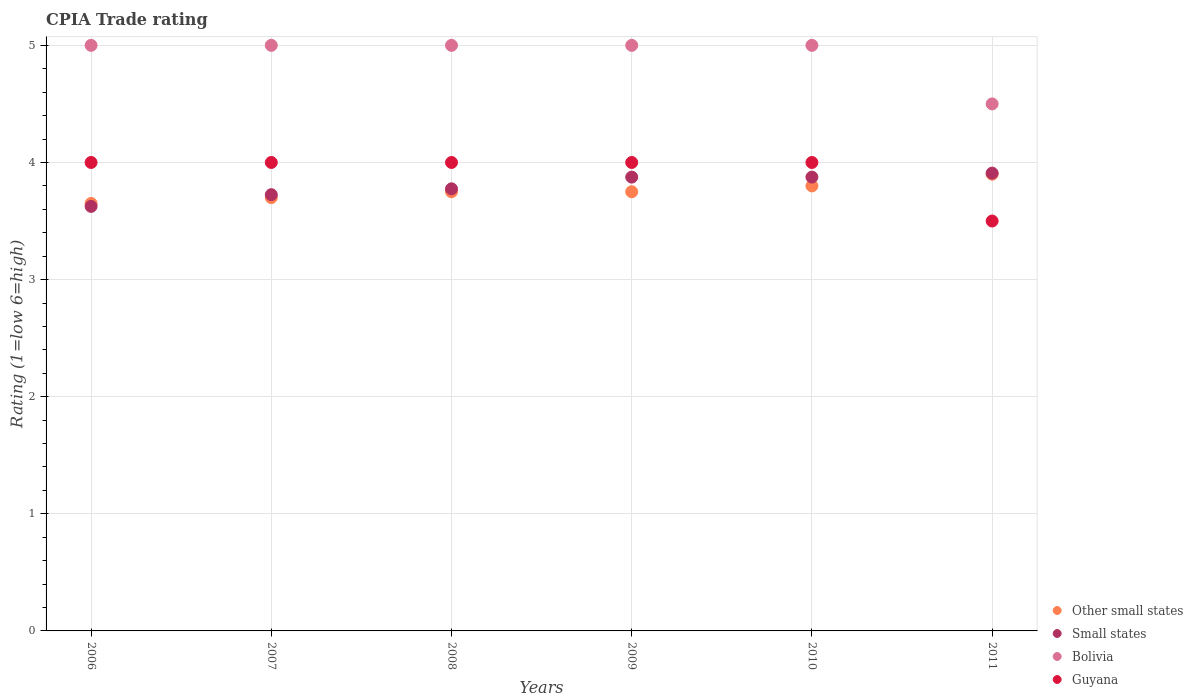Is the number of dotlines equal to the number of legend labels?
Give a very brief answer. Yes. What is the CPIA rating in Guyana in 2010?
Your response must be concise. 4. Across all years, what is the minimum CPIA rating in Small states?
Ensure brevity in your answer.  3.62. In which year was the CPIA rating in Other small states minimum?
Offer a very short reply. 2006. What is the average CPIA rating in Other small states per year?
Your answer should be compact. 3.76. In the year 2007, what is the difference between the CPIA rating in Bolivia and CPIA rating in Guyana?
Make the answer very short. 1. In how many years, is the CPIA rating in Bolivia greater than 4.6?
Your answer should be compact. 5. What is the ratio of the CPIA rating in Small states in 2009 to that in 2011?
Provide a short and direct response. 0.99. Is the CPIA rating in Other small states in 2008 less than that in 2009?
Offer a terse response. No. What is the difference between the highest and the second highest CPIA rating in Small states?
Your answer should be compact. 0.03. What is the difference between the highest and the lowest CPIA rating in Other small states?
Make the answer very short. 0.25. In how many years, is the CPIA rating in Bolivia greater than the average CPIA rating in Bolivia taken over all years?
Provide a succinct answer. 5. Is the sum of the CPIA rating in Small states in 2006 and 2011 greater than the maximum CPIA rating in Guyana across all years?
Your response must be concise. Yes. Does the CPIA rating in Bolivia monotonically increase over the years?
Make the answer very short. No. Is the CPIA rating in Small states strictly greater than the CPIA rating in Other small states over the years?
Your answer should be very brief. No. Is the CPIA rating in Bolivia strictly less than the CPIA rating in Small states over the years?
Make the answer very short. No. How many years are there in the graph?
Your response must be concise. 6. What is the difference between two consecutive major ticks on the Y-axis?
Make the answer very short. 1. Are the values on the major ticks of Y-axis written in scientific E-notation?
Offer a terse response. No. Does the graph contain grids?
Offer a terse response. Yes. Where does the legend appear in the graph?
Give a very brief answer. Bottom right. How many legend labels are there?
Ensure brevity in your answer.  4. How are the legend labels stacked?
Your answer should be compact. Vertical. What is the title of the graph?
Make the answer very short. CPIA Trade rating. What is the Rating (1=low 6=high) in Other small states in 2006?
Give a very brief answer. 3.65. What is the Rating (1=low 6=high) in Small states in 2006?
Provide a short and direct response. 3.62. What is the Rating (1=low 6=high) in Guyana in 2006?
Give a very brief answer. 4. What is the Rating (1=low 6=high) of Other small states in 2007?
Ensure brevity in your answer.  3.7. What is the Rating (1=low 6=high) in Small states in 2007?
Make the answer very short. 3.73. What is the Rating (1=low 6=high) in Guyana in 2007?
Ensure brevity in your answer.  4. What is the Rating (1=low 6=high) of Other small states in 2008?
Offer a very short reply. 3.75. What is the Rating (1=low 6=high) in Small states in 2008?
Ensure brevity in your answer.  3.77. What is the Rating (1=low 6=high) of Bolivia in 2008?
Your response must be concise. 5. What is the Rating (1=low 6=high) of Guyana in 2008?
Your answer should be compact. 4. What is the Rating (1=low 6=high) of Other small states in 2009?
Give a very brief answer. 3.75. What is the Rating (1=low 6=high) in Small states in 2009?
Give a very brief answer. 3.88. What is the Rating (1=low 6=high) of Small states in 2010?
Offer a very short reply. 3.88. What is the Rating (1=low 6=high) of Bolivia in 2010?
Offer a very short reply. 5. What is the Rating (1=low 6=high) in Guyana in 2010?
Give a very brief answer. 4. What is the Rating (1=low 6=high) in Other small states in 2011?
Make the answer very short. 3.9. What is the Rating (1=low 6=high) in Small states in 2011?
Ensure brevity in your answer.  3.91. What is the Rating (1=low 6=high) in Bolivia in 2011?
Ensure brevity in your answer.  4.5. What is the Rating (1=low 6=high) in Guyana in 2011?
Provide a succinct answer. 3.5. Across all years, what is the maximum Rating (1=low 6=high) of Small states?
Make the answer very short. 3.91. Across all years, what is the minimum Rating (1=low 6=high) in Other small states?
Your answer should be very brief. 3.65. Across all years, what is the minimum Rating (1=low 6=high) in Small states?
Your answer should be very brief. 3.62. Across all years, what is the minimum Rating (1=low 6=high) of Guyana?
Give a very brief answer. 3.5. What is the total Rating (1=low 6=high) in Other small states in the graph?
Your response must be concise. 22.55. What is the total Rating (1=low 6=high) in Small states in the graph?
Your response must be concise. 22.78. What is the total Rating (1=low 6=high) in Bolivia in the graph?
Your answer should be compact. 29.5. What is the total Rating (1=low 6=high) of Guyana in the graph?
Your answer should be very brief. 23.5. What is the difference between the Rating (1=low 6=high) of Other small states in 2006 and that in 2007?
Keep it short and to the point. -0.05. What is the difference between the Rating (1=low 6=high) in Small states in 2006 and that in 2007?
Provide a succinct answer. -0.1. What is the difference between the Rating (1=low 6=high) of Guyana in 2006 and that in 2007?
Make the answer very short. 0. What is the difference between the Rating (1=low 6=high) of Small states in 2006 and that in 2008?
Give a very brief answer. -0.15. What is the difference between the Rating (1=low 6=high) of Bolivia in 2006 and that in 2008?
Provide a succinct answer. 0. What is the difference between the Rating (1=low 6=high) of Guyana in 2006 and that in 2008?
Your answer should be very brief. 0. What is the difference between the Rating (1=low 6=high) of Small states in 2006 and that in 2009?
Provide a short and direct response. -0.25. What is the difference between the Rating (1=low 6=high) in Small states in 2006 and that in 2010?
Your response must be concise. -0.25. What is the difference between the Rating (1=low 6=high) in Other small states in 2006 and that in 2011?
Your response must be concise. -0.25. What is the difference between the Rating (1=low 6=high) in Small states in 2006 and that in 2011?
Make the answer very short. -0.28. What is the difference between the Rating (1=low 6=high) in Bolivia in 2006 and that in 2011?
Your answer should be very brief. 0.5. What is the difference between the Rating (1=low 6=high) of Guyana in 2006 and that in 2011?
Your answer should be very brief. 0.5. What is the difference between the Rating (1=low 6=high) of Small states in 2007 and that in 2008?
Your response must be concise. -0.05. What is the difference between the Rating (1=low 6=high) of Bolivia in 2007 and that in 2009?
Your answer should be compact. 0. What is the difference between the Rating (1=low 6=high) of Guyana in 2007 and that in 2009?
Ensure brevity in your answer.  0. What is the difference between the Rating (1=low 6=high) of Other small states in 2007 and that in 2010?
Provide a succinct answer. -0.1. What is the difference between the Rating (1=low 6=high) in Bolivia in 2007 and that in 2010?
Offer a terse response. 0. What is the difference between the Rating (1=low 6=high) of Guyana in 2007 and that in 2010?
Give a very brief answer. 0. What is the difference between the Rating (1=low 6=high) of Small states in 2007 and that in 2011?
Give a very brief answer. -0.18. What is the difference between the Rating (1=low 6=high) in Bolivia in 2007 and that in 2011?
Provide a succinct answer. 0.5. What is the difference between the Rating (1=low 6=high) of Guyana in 2007 and that in 2011?
Offer a terse response. 0.5. What is the difference between the Rating (1=low 6=high) of Small states in 2008 and that in 2009?
Your answer should be compact. -0.1. What is the difference between the Rating (1=low 6=high) in Bolivia in 2008 and that in 2009?
Offer a very short reply. 0. What is the difference between the Rating (1=low 6=high) of Guyana in 2008 and that in 2009?
Ensure brevity in your answer.  0. What is the difference between the Rating (1=low 6=high) of Other small states in 2008 and that in 2010?
Provide a short and direct response. -0.05. What is the difference between the Rating (1=low 6=high) in Small states in 2008 and that in 2010?
Make the answer very short. -0.1. What is the difference between the Rating (1=low 6=high) in Bolivia in 2008 and that in 2010?
Your answer should be very brief. 0. What is the difference between the Rating (1=low 6=high) of Guyana in 2008 and that in 2010?
Provide a succinct answer. 0. What is the difference between the Rating (1=low 6=high) of Other small states in 2008 and that in 2011?
Your answer should be very brief. -0.15. What is the difference between the Rating (1=low 6=high) in Small states in 2008 and that in 2011?
Make the answer very short. -0.13. What is the difference between the Rating (1=low 6=high) of Bolivia in 2008 and that in 2011?
Give a very brief answer. 0.5. What is the difference between the Rating (1=low 6=high) of Guyana in 2008 and that in 2011?
Offer a terse response. 0.5. What is the difference between the Rating (1=low 6=high) in Small states in 2009 and that in 2010?
Your response must be concise. 0. What is the difference between the Rating (1=low 6=high) of Bolivia in 2009 and that in 2010?
Offer a very short reply. 0. What is the difference between the Rating (1=low 6=high) in Guyana in 2009 and that in 2010?
Your answer should be very brief. 0. What is the difference between the Rating (1=low 6=high) in Other small states in 2009 and that in 2011?
Your answer should be very brief. -0.15. What is the difference between the Rating (1=low 6=high) of Small states in 2009 and that in 2011?
Offer a very short reply. -0.03. What is the difference between the Rating (1=low 6=high) in Bolivia in 2009 and that in 2011?
Offer a terse response. 0.5. What is the difference between the Rating (1=low 6=high) of Small states in 2010 and that in 2011?
Ensure brevity in your answer.  -0.03. What is the difference between the Rating (1=low 6=high) in Bolivia in 2010 and that in 2011?
Make the answer very short. 0.5. What is the difference between the Rating (1=low 6=high) in Guyana in 2010 and that in 2011?
Offer a very short reply. 0.5. What is the difference between the Rating (1=low 6=high) in Other small states in 2006 and the Rating (1=low 6=high) in Small states in 2007?
Keep it short and to the point. -0.07. What is the difference between the Rating (1=low 6=high) of Other small states in 2006 and the Rating (1=low 6=high) of Bolivia in 2007?
Ensure brevity in your answer.  -1.35. What is the difference between the Rating (1=low 6=high) of Other small states in 2006 and the Rating (1=low 6=high) of Guyana in 2007?
Provide a succinct answer. -0.35. What is the difference between the Rating (1=low 6=high) in Small states in 2006 and the Rating (1=low 6=high) in Bolivia in 2007?
Offer a terse response. -1.38. What is the difference between the Rating (1=low 6=high) of Small states in 2006 and the Rating (1=low 6=high) of Guyana in 2007?
Give a very brief answer. -0.38. What is the difference between the Rating (1=low 6=high) in Other small states in 2006 and the Rating (1=low 6=high) in Small states in 2008?
Provide a succinct answer. -0.12. What is the difference between the Rating (1=low 6=high) of Other small states in 2006 and the Rating (1=low 6=high) of Bolivia in 2008?
Your answer should be very brief. -1.35. What is the difference between the Rating (1=low 6=high) in Other small states in 2006 and the Rating (1=low 6=high) in Guyana in 2008?
Provide a short and direct response. -0.35. What is the difference between the Rating (1=low 6=high) in Small states in 2006 and the Rating (1=low 6=high) in Bolivia in 2008?
Provide a succinct answer. -1.38. What is the difference between the Rating (1=low 6=high) in Small states in 2006 and the Rating (1=low 6=high) in Guyana in 2008?
Provide a succinct answer. -0.38. What is the difference between the Rating (1=low 6=high) of Bolivia in 2006 and the Rating (1=low 6=high) of Guyana in 2008?
Your response must be concise. 1. What is the difference between the Rating (1=low 6=high) in Other small states in 2006 and the Rating (1=low 6=high) in Small states in 2009?
Offer a very short reply. -0.23. What is the difference between the Rating (1=low 6=high) of Other small states in 2006 and the Rating (1=low 6=high) of Bolivia in 2009?
Keep it short and to the point. -1.35. What is the difference between the Rating (1=low 6=high) in Other small states in 2006 and the Rating (1=low 6=high) in Guyana in 2009?
Offer a terse response. -0.35. What is the difference between the Rating (1=low 6=high) in Small states in 2006 and the Rating (1=low 6=high) in Bolivia in 2009?
Provide a succinct answer. -1.38. What is the difference between the Rating (1=low 6=high) of Small states in 2006 and the Rating (1=low 6=high) of Guyana in 2009?
Ensure brevity in your answer.  -0.38. What is the difference between the Rating (1=low 6=high) in Other small states in 2006 and the Rating (1=low 6=high) in Small states in 2010?
Provide a short and direct response. -0.23. What is the difference between the Rating (1=low 6=high) of Other small states in 2006 and the Rating (1=low 6=high) of Bolivia in 2010?
Give a very brief answer. -1.35. What is the difference between the Rating (1=low 6=high) in Other small states in 2006 and the Rating (1=low 6=high) in Guyana in 2010?
Provide a succinct answer. -0.35. What is the difference between the Rating (1=low 6=high) of Small states in 2006 and the Rating (1=low 6=high) of Bolivia in 2010?
Your answer should be compact. -1.38. What is the difference between the Rating (1=low 6=high) in Small states in 2006 and the Rating (1=low 6=high) in Guyana in 2010?
Your answer should be very brief. -0.38. What is the difference between the Rating (1=low 6=high) in Other small states in 2006 and the Rating (1=low 6=high) in Small states in 2011?
Your response must be concise. -0.26. What is the difference between the Rating (1=low 6=high) in Other small states in 2006 and the Rating (1=low 6=high) in Bolivia in 2011?
Your response must be concise. -0.85. What is the difference between the Rating (1=low 6=high) in Small states in 2006 and the Rating (1=low 6=high) in Bolivia in 2011?
Provide a short and direct response. -0.88. What is the difference between the Rating (1=low 6=high) in Small states in 2006 and the Rating (1=low 6=high) in Guyana in 2011?
Offer a terse response. 0.12. What is the difference between the Rating (1=low 6=high) in Bolivia in 2006 and the Rating (1=low 6=high) in Guyana in 2011?
Give a very brief answer. 1.5. What is the difference between the Rating (1=low 6=high) of Other small states in 2007 and the Rating (1=low 6=high) of Small states in 2008?
Your answer should be very brief. -0.07. What is the difference between the Rating (1=low 6=high) of Small states in 2007 and the Rating (1=low 6=high) of Bolivia in 2008?
Your answer should be very brief. -1.27. What is the difference between the Rating (1=low 6=high) in Small states in 2007 and the Rating (1=low 6=high) in Guyana in 2008?
Provide a short and direct response. -0.28. What is the difference between the Rating (1=low 6=high) in Bolivia in 2007 and the Rating (1=low 6=high) in Guyana in 2008?
Provide a succinct answer. 1. What is the difference between the Rating (1=low 6=high) of Other small states in 2007 and the Rating (1=low 6=high) of Small states in 2009?
Provide a short and direct response. -0.17. What is the difference between the Rating (1=low 6=high) of Other small states in 2007 and the Rating (1=low 6=high) of Bolivia in 2009?
Your response must be concise. -1.3. What is the difference between the Rating (1=low 6=high) of Small states in 2007 and the Rating (1=low 6=high) of Bolivia in 2009?
Make the answer very short. -1.27. What is the difference between the Rating (1=low 6=high) in Small states in 2007 and the Rating (1=low 6=high) in Guyana in 2009?
Ensure brevity in your answer.  -0.28. What is the difference between the Rating (1=low 6=high) of Bolivia in 2007 and the Rating (1=low 6=high) of Guyana in 2009?
Provide a succinct answer. 1. What is the difference between the Rating (1=low 6=high) of Other small states in 2007 and the Rating (1=low 6=high) of Small states in 2010?
Offer a terse response. -0.17. What is the difference between the Rating (1=low 6=high) of Small states in 2007 and the Rating (1=low 6=high) of Bolivia in 2010?
Provide a short and direct response. -1.27. What is the difference between the Rating (1=low 6=high) of Small states in 2007 and the Rating (1=low 6=high) of Guyana in 2010?
Offer a very short reply. -0.28. What is the difference between the Rating (1=low 6=high) in Bolivia in 2007 and the Rating (1=low 6=high) in Guyana in 2010?
Your response must be concise. 1. What is the difference between the Rating (1=low 6=high) in Other small states in 2007 and the Rating (1=low 6=high) in Small states in 2011?
Give a very brief answer. -0.21. What is the difference between the Rating (1=low 6=high) of Other small states in 2007 and the Rating (1=low 6=high) of Guyana in 2011?
Provide a short and direct response. 0.2. What is the difference between the Rating (1=low 6=high) in Small states in 2007 and the Rating (1=low 6=high) in Bolivia in 2011?
Your answer should be compact. -0.78. What is the difference between the Rating (1=low 6=high) in Small states in 2007 and the Rating (1=low 6=high) in Guyana in 2011?
Provide a succinct answer. 0.23. What is the difference between the Rating (1=low 6=high) in Bolivia in 2007 and the Rating (1=low 6=high) in Guyana in 2011?
Make the answer very short. 1.5. What is the difference between the Rating (1=low 6=high) of Other small states in 2008 and the Rating (1=low 6=high) of Small states in 2009?
Ensure brevity in your answer.  -0.12. What is the difference between the Rating (1=low 6=high) in Other small states in 2008 and the Rating (1=low 6=high) in Bolivia in 2009?
Offer a terse response. -1.25. What is the difference between the Rating (1=low 6=high) in Other small states in 2008 and the Rating (1=low 6=high) in Guyana in 2009?
Make the answer very short. -0.25. What is the difference between the Rating (1=low 6=high) of Small states in 2008 and the Rating (1=low 6=high) of Bolivia in 2009?
Keep it short and to the point. -1.23. What is the difference between the Rating (1=low 6=high) of Small states in 2008 and the Rating (1=low 6=high) of Guyana in 2009?
Make the answer very short. -0.23. What is the difference between the Rating (1=low 6=high) in Bolivia in 2008 and the Rating (1=low 6=high) in Guyana in 2009?
Provide a short and direct response. 1. What is the difference between the Rating (1=low 6=high) of Other small states in 2008 and the Rating (1=low 6=high) of Small states in 2010?
Offer a terse response. -0.12. What is the difference between the Rating (1=low 6=high) of Other small states in 2008 and the Rating (1=low 6=high) of Bolivia in 2010?
Your answer should be compact. -1.25. What is the difference between the Rating (1=low 6=high) of Other small states in 2008 and the Rating (1=low 6=high) of Guyana in 2010?
Give a very brief answer. -0.25. What is the difference between the Rating (1=low 6=high) of Small states in 2008 and the Rating (1=low 6=high) of Bolivia in 2010?
Offer a very short reply. -1.23. What is the difference between the Rating (1=low 6=high) in Small states in 2008 and the Rating (1=low 6=high) in Guyana in 2010?
Keep it short and to the point. -0.23. What is the difference between the Rating (1=low 6=high) in Other small states in 2008 and the Rating (1=low 6=high) in Small states in 2011?
Your response must be concise. -0.16. What is the difference between the Rating (1=low 6=high) in Other small states in 2008 and the Rating (1=low 6=high) in Bolivia in 2011?
Provide a short and direct response. -0.75. What is the difference between the Rating (1=low 6=high) in Small states in 2008 and the Rating (1=low 6=high) in Bolivia in 2011?
Keep it short and to the point. -0.72. What is the difference between the Rating (1=low 6=high) in Small states in 2008 and the Rating (1=low 6=high) in Guyana in 2011?
Provide a succinct answer. 0.28. What is the difference between the Rating (1=low 6=high) of Bolivia in 2008 and the Rating (1=low 6=high) of Guyana in 2011?
Make the answer very short. 1.5. What is the difference between the Rating (1=low 6=high) in Other small states in 2009 and the Rating (1=low 6=high) in Small states in 2010?
Ensure brevity in your answer.  -0.12. What is the difference between the Rating (1=low 6=high) in Other small states in 2009 and the Rating (1=low 6=high) in Bolivia in 2010?
Your response must be concise. -1.25. What is the difference between the Rating (1=low 6=high) of Small states in 2009 and the Rating (1=low 6=high) of Bolivia in 2010?
Your answer should be compact. -1.12. What is the difference between the Rating (1=low 6=high) in Small states in 2009 and the Rating (1=low 6=high) in Guyana in 2010?
Offer a very short reply. -0.12. What is the difference between the Rating (1=low 6=high) in Bolivia in 2009 and the Rating (1=low 6=high) in Guyana in 2010?
Give a very brief answer. 1. What is the difference between the Rating (1=low 6=high) of Other small states in 2009 and the Rating (1=low 6=high) of Small states in 2011?
Make the answer very short. -0.16. What is the difference between the Rating (1=low 6=high) in Other small states in 2009 and the Rating (1=low 6=high) in Bolivia in 2011?
Offer a terse response. -0.75. What is the difference between the Rating (1=low 6=high) of Small states in 2009 and the Rating (1=low 6=high) of Bolivia in 2011?
Keep it short and to the point. -0.62. What is the difference between the Rating (1=low 6=high) of Small states in 2009 and the Rating (1=low 6=high) of Guyana in 2011?
Offer a very short reply. 0.38. What is the difference between the Rating (1=low 6=high) in Bolivia in 2009 and the Rating (1=low 6=high) in Guyana in 2011?
Keep it short and to the point. 1.5. What is the difference between the Rating (1=low 6=high) in Other small states in 2010 and the Rating (1=low 6=high) in Small states in 2011?
Your answer should be very brief. -0.11. What is the difference between the Rating (1=low 6=high) of Small states in 2010 and the Rating (1=low 6=high) of Bolivia in 2011?
Provide a succinct answer. -0.62. What is the difference between the Rating (1=low 6=high) in Small states in 2010 and the Rating (1=low 6=high) in Guyana in 2011?
Give a very brief answer. 0.38. What is the difference between the Rating (1=low 6=high) of Bolivia in 2010 and the Rating (1=low 6=high) of Guyana in 2011?
Keep it short and to the point. 1.5. What is the average Rating (1=low 6=high) of Other small states per year?
Ensure brevity in your answer.  3.76. What is the average Rating (1=low 6=high) in Small states per year?
Your answer should be very brief. 3.8. What is the average Rating (1=low 6=high) in Bolivia per year?
Offer a very short reply. 4.92. What is the average Rating (1=low 6=high) in Guyana per year?
Give a very brief answer. 3.92. In the year 2006, what is the difference between the Rating (1=low 6=high) in Other small states and Rating (1=low 6=high) in Small states?
Ensure brevity in your answer.  0.03. In the year 2006, what is the difference between the Rating (1=low 6=high) in Other small states and Rating (1=low 6=high) in Bolivia?
Keep it short and to the point. -1.35. In the year 2006, what is the difference between the Rating (1=low 6=high) in Other small states and Rating (1=low 6=high) in Guyana?
Provide a succinct answer. -0.35. In the year 2006, what is the difference between the Rating (1=low 6=high) in Small states and Rating (1=low 6=high) in Bolivia?
Give a very brief answer. -1.38. In the year 2006, what is the difference between the Rating (1=low 6=high) in Small states and Rating (1=low 6=high) in Guyana?
Keep it short and to the point. -0.38. In the year 2006, what is the difference between the Rating (1=low 6=high) in Bolivia and Rating (1=low 6=high) in Guyana?
Offer a very short reply. 1. In the year 2007, what is the difference between the Rating (1=low 6=high) of Other small states and Rating (1=low 6=high) of Small states?
Keep it short and to the point. -0.03. In the year 2007, what is the difference between the Rating (1=low 6=high) of Small states and Rating (1=low 6=high) of Bolivia?
Ensure brevity in your answer.  -1.27. In the year 2007, what is the difference between the Rating (1=low 6=high) in Small states and Rating (1=low 6=high) in Guyana?
Your response must be concise. -0.28. In the year 2008, what is the difference between the Rating (1=low 6=high) of Other small states and Rating (1=low 6=high) of Small states?
Offer a terse response. -0.03. In the year 2008, what is the difference between the Rating (1=low 6=high) of Other small states and Rating (1=low 6=high) of Bolivia?
Ensure brevity in your answer.  -1.25. In the year 2008, what is the difference between the Rating (1=low 6=high) in Small states and Rating (1=low 6=high) in Bolivia?
Keep it short and to the point. -1.23. In the year 2008, what is the difference between the Rating (1=low 6=high) in Small states and Rating (1=low 6=high) in Guyana?
Ensure brevity in your answer.  -0.23. In the year 2009, what is the difference between the Rating (1=low 6=high) in Other small states and Rating (1=low 6=high) in Small states?
Your answer should be very brief. -0.12. In the year 2009, what is the difference between the Rating (1=low 6=high) of Other small states and Rating (1=low 6=high) of Bolivia?
Keep it short and to the point. -1.25. In the year 2009, what is the difference between the Rating (1=low 6=high) in Small states and Rating (1=low 6=high) in Bolivia?
Provide a short and direct response. -1.12. In the year 2009, what is the difference between the Rating (1=low 6=high) of Small states and Rating (1=low 6=high) of Guyana?
Your answer should be compact. -0.12. In the year 2009, what is the difference between the Rating (1=low 6=high) in Bolivia and Rating (1=low 6=high) in Guyana?
Provide a short and direct response. 1. In the year 2010, what is the difference between the Rating (1=low 6=high) in Other small states and Rating (1=low 6=high) in Small states?
Ensure brevity in your answer.  -0.07. In the year 2010, what is the difference between the Rating (1=low 6=high) of Other small states and Rating (1=low 6=high) of Bolivia?
Provide a succinct answer. -1.2. In the year 2010, what is the difference between the Rating (1=low 6=high) of Other small states and Rating (1=low 6=high) of Guyana?
Keep it short and to the point. -0.2. In the year 2010, what is the difference between the Rating (1=low 6=high) in Small states and Rating (1=low 6=high) in Bolivia?
Ensure brevity in your answer.  -1.12. In the year 2010, what is the difference between the Rating (1=low 6=high) in Small states and Rating (1=low 6=high) in Guyana?
Your answer should be very brief. -0.12. In the year 2010, what is the difference between the Rating (1=low 6=high) of Bolivia and Rating (1=low 6=high) of Guyana?
Provide a succinct answer. 1. In the year 2011, what is the difference between the Rating (1=low 6=high) of Other small states and Rating (1=low 6=high) of Small states?
Keep it short and to the point. -0.01. In the year 2011, what is the difference between the Rating (1=low 6=high) of Small states and Rating (1=low 6=high) of Bolivia?
Offer a very short reply. -0.59. In the year 2011, what is the difference between the Rating (1=low 6=high) in Small states and Rating (1=low 6=high) in Guyana?
Your answer should be compact. 0.41. In the year 2011, what is the difference between the Rating (1=low 6=high) in Bolivia and Rating (1=low 6=high) in Guyana?
Your answer should be compact. 1. What is the ratio of the Rating (1=low 6=high) in Other small states in 2006 to that in 2007?
Your answer should be compact. 0.99. What is the ratio of the Rating (1=low 6=high) in Small states in 2006 to that in 2007?
Offer a terse response. 0.97. What is the ratio of the Rating (1=low 6=high) in Bolivia in 2006 to that in 2007?
Provide a short and direct response. 1. What is the ratio of the Rating (1=low 6=high) of Other small states in 2006 to that in 2008?
Your answer should be very brief. 0.97. What is the ratio of the Rating (1=low 6=high) of Small states in 2006 to that in 2008?
Your answer should be very brief. 0.96. What is the ratio of the Rating (1=low 6=high) of Bolivia in 2006 to that in 2008?
Offer a very short reply. 1. What is the ratio of the Rating (1=low 6=high) in Guyana in 2006 to that in 2008?
Your answer should be compact. 1. What is the ratio of the Rating (1=low 6=high) in Other small states in 2006 to that in 2009?
Make the answer very short. 0.97. What is the ratio of the Rating (1=low 6=high) in Small states in 2006 to that in 2009?
Ensure brevity in your answer.  0.94. What is the ratio of the Rating (1=low 6=high) of Guyana in 2006 to that in 2009?
Offer a terse response. 1. What is the ratio of the Rating (1=low 6=high) of Other small states in 2006 to that in 2010?
Provide a succinct answer. 0.96. What is the ratio of the Rating (1=low 6=high) in Small states in 2006 to that in 2010?
Offer a very short reply. 0.94. What is the ratio of the Rating (1=low 6=high) in Other small states in 2006 to that in 2011?
Your answer should be compact. 0.94. What is the ratio of the Rating (1=low 6=high) of Small states in 2006 to that in 2011?
Make the answer very short. 0.93. What is the ratio of the Rating (1=low 6=high) of Guyana in 2006 to that in 2011?
Provide a succinct answer. 1.14. What is the ratio of the Rating (1=low 6=high) in Other small states in 2007 to that in 2008?
Offer a terse response. 0.99. What is the ratio of the Rating (1=low 6=high) in Bolivia in 2007 to that in 2008?
Offer a very short reply. 1. What is the ratio of the Rating (1=low 6=high) in Other small states in 2007 to that in 2009?
Provide a succinct answer. 0.99. What is the ratio of the Rating (1=low 6=high) of Small states in 2007 to that in 2009?
Offer a terse response. 0.96. What is the ratio of the Rating (1=low 6=high) in Guyana in 2007 to that in 2009?
Provide a succinct answer. 1. What is the ratio of the Rating (1=low 6=high) of Other small states in 2007 to that in 2010?
Your response must be concise. 0.97. What is the ratio of the Rating (1=low 6=high) of Small states in 2007 to that in 2010?
Keep it short and to the point. 0.96. What is the ratio of the Rating (1=low 6=high) of Other small states in 2007 to that in 2011?
Offer a very short reply. 0.95. What is the ratio of the Rating (1=low 6=high) in Small states in 2007 to that in 2011?
Offer a terse response. 0.95. What is the ratio of the Rating (1=low 6=high) in Other small states in 2008 to that in 2009?
Your answer should be very brief. 1. What is the ratio of the Rating (1=low 6=high) in Small states in 2008 to that in 2009?
Give a very brief answer. 0.97. What is the ratio of the Rating (1=low 6=high) of Guyana in 2008 to that in 2009?
Provide a succinct answer. 1. What is the ratio of the Rating (1=low 6=high) in Other small states in 2008 to that in 2010?
Offer a terse response. 0.99. What is the ratio of the Rating (1=low 6=high) in Small states in 2008 to that in 2010?
Your answer should be very brief. 0.97. What is the ratio of the Rating (1=low 6=high) in Bolivia in 2008 to that in 2010?
Your response must be concise. 1. What is the ratio of the Rating (1=low 6=high) in Guyana in 2008 to that in 2010?
Your answer should be compact. 1. What is the ratio of the Rating (1=low 6=high) of Other small states in 2008 to that in 2011?
Keep it short and to the point. 0.96. What is the ratio of the Rating (1=low 6=high) in Small states in 2008 to that in 2011?
Your answer should be compact. 0.97. What is the ratio of the Rating (1=low 6=high) in Bolivia in 2008 to that in 2011?
Offer a very short reply. 1.11. What is the ratio of the Rating (1=low 6=high) of Other small states in 2009 to that in 2010?
Provide a succinct answer. 0.99. What is the ratio of the Rating (1=low 6=high) of Bolivia in 2009 to that in 2010?
Your answer should be compact. 1. What is the ratio of the Rating (1=low 6=high) of Other small states in 2009 to that in 2011?
Your response must be concise. 0.96. What is the ratio of the Rating (1=low 6=high) in Small states in 2009 to that in 2011?
Provide a short and direct response. 0.99. What is the ratio of the Rating (1=low 6=high) in Bolivia in 2009 to that in 2011?
Offer a very short reply. 1.11. What is the ratio of the Rating (1=low 6=high) in Guyana in 2009 to that in 2011?
Your answer should be compact. 1.14. What is the ratio of the Rating (1=low 6=high) in Other small states in 2010 to that in 2011?
Ensure brevity in your answer.  0.97. What is the ratio of the Rating (1=low 6=high) in Bolivia in 2010 to that in 2011?
Offer a very short reply. 1.11. What is the ratio of the Rating (1=low 6=high) of Guyana in 2010 to that in 2011?
Give a very brief answer. 1.14. What is the difference between the highest and the second highest Rating (1=low 6=high) of Other small states?
Give a very brief answer. 0.1. What is the difference between the highest and the second highest Rating (1=low 6=high) in Small states?
Ensure brevity in your answer.  0.03. What is the difference between the highest and the lowest Rating (1=low 6=high) in Small states?
Your answer should be compact. 0.28. 